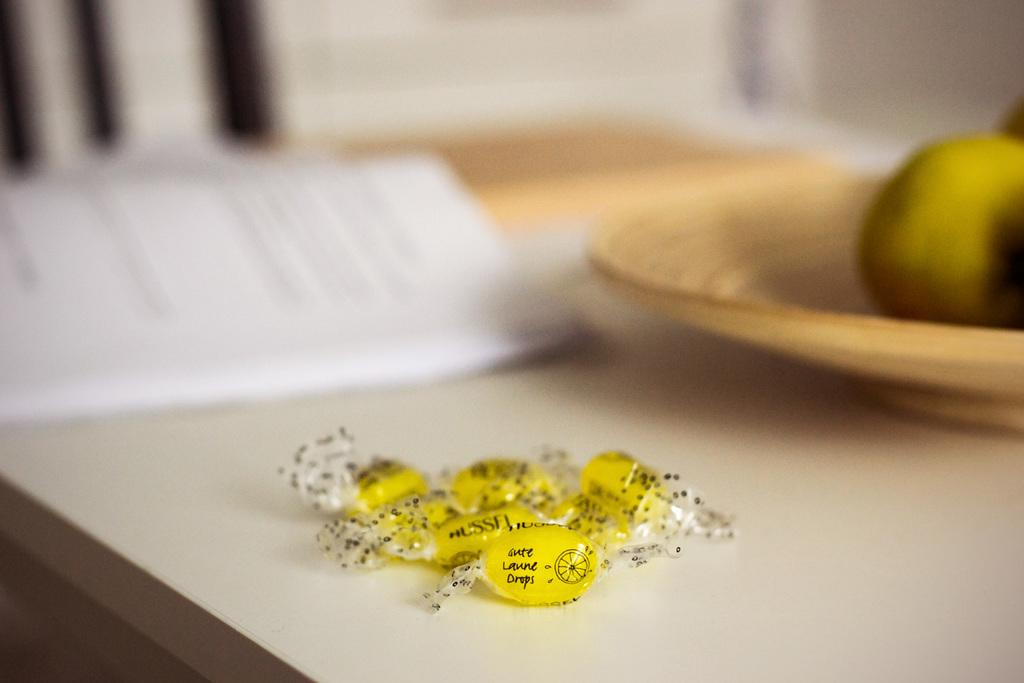What type of food can be seen on the table in the image? There are candies on the table in the image. What else is present on the table besides candies? There are other objects on the table. Can you describe the background of the image? The background of the image is blurred. What type of cake is being played on a scale in the image? There is no cake, play, or scale present in the image. 